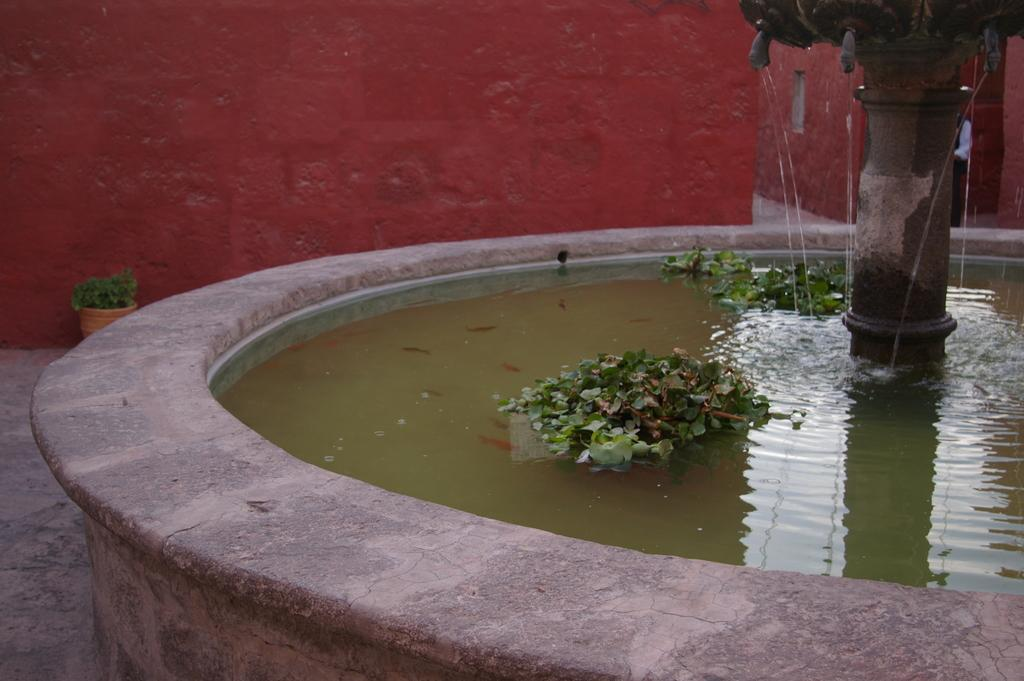What is the main feature in the image? There is a fountain in the image. What else can be seen in the image besides the fountain? There are house plants and a person in the image. What is the background of the image? There is a wall in the image. When was the image taken? The image was taken during the day. What type of brake is being used by the person in the image? There is no brake present in the image, as it features a fountain, house plants, a person, and a wall. --- Facts: 1. There is a car in the image. 2. The car is red. 3. The car has four wheels. 4. There is a road in the image. 5. The road is paved. Absurd Topics: parrot, sand, dance Conversation: What is the main subject of the image? The main subject of the image is a car. What color is the car? The car is red. How many wheels does the car have? The car has four wheels. What is the setting of the image? There is a road in the image. What type of road is visible in the image? The road is paved. Reasoning: Let's think step by step in order to produce the conversation. We start by identifying the main subject in the image, which is the car. Then, we expand the conversation to include other details about the car, such as its color and the number of wheels. We also describe the setting of the image, which includes a road, and provide information about the road's surface. Each question is designed to elicit a specific detail about the image that is known from the provided facts. Absurd Question/Answer: Can you tell me how many parrots are sitting on the car in the image? There are no parrots present in the image; it features a red car with four wheels on a paved road. --- Facts: 1. There is a beach in the image. 2. There are people in the image. 3. The people are wearing swimsuits. 4. There is a lifeguard tower in the image. 5. The sky is blue. Absurd Topics: snow, book, robot Conversation: What is the main setting of the image? The main setting of the image is a beach. Who is present in the image? There are people in the image. What are the people wearing? The people are wearing swimsuits. What safety feature can be seen in the image? There is a lifeguard tower in the image. What is the color of the sky in the image? The sky is blue in the image. 